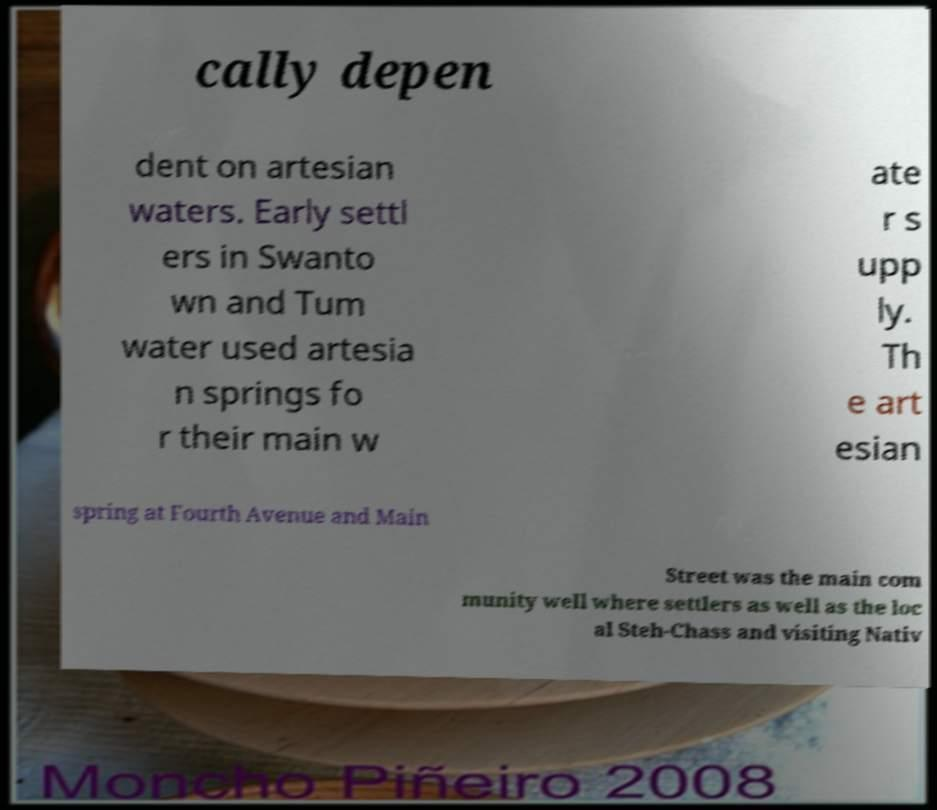Could you extract and type out the text from this image? cally depen dent on artesian waters. Early settl ers in Swanto wn and Tum water used artesia n springs fo r their main w ate r s upp ly. Th e art esian spring at Fourth Avenue and Main Street was the main com munity well where settlers as well as the loc al Steh-Chass and visiting Nativ 